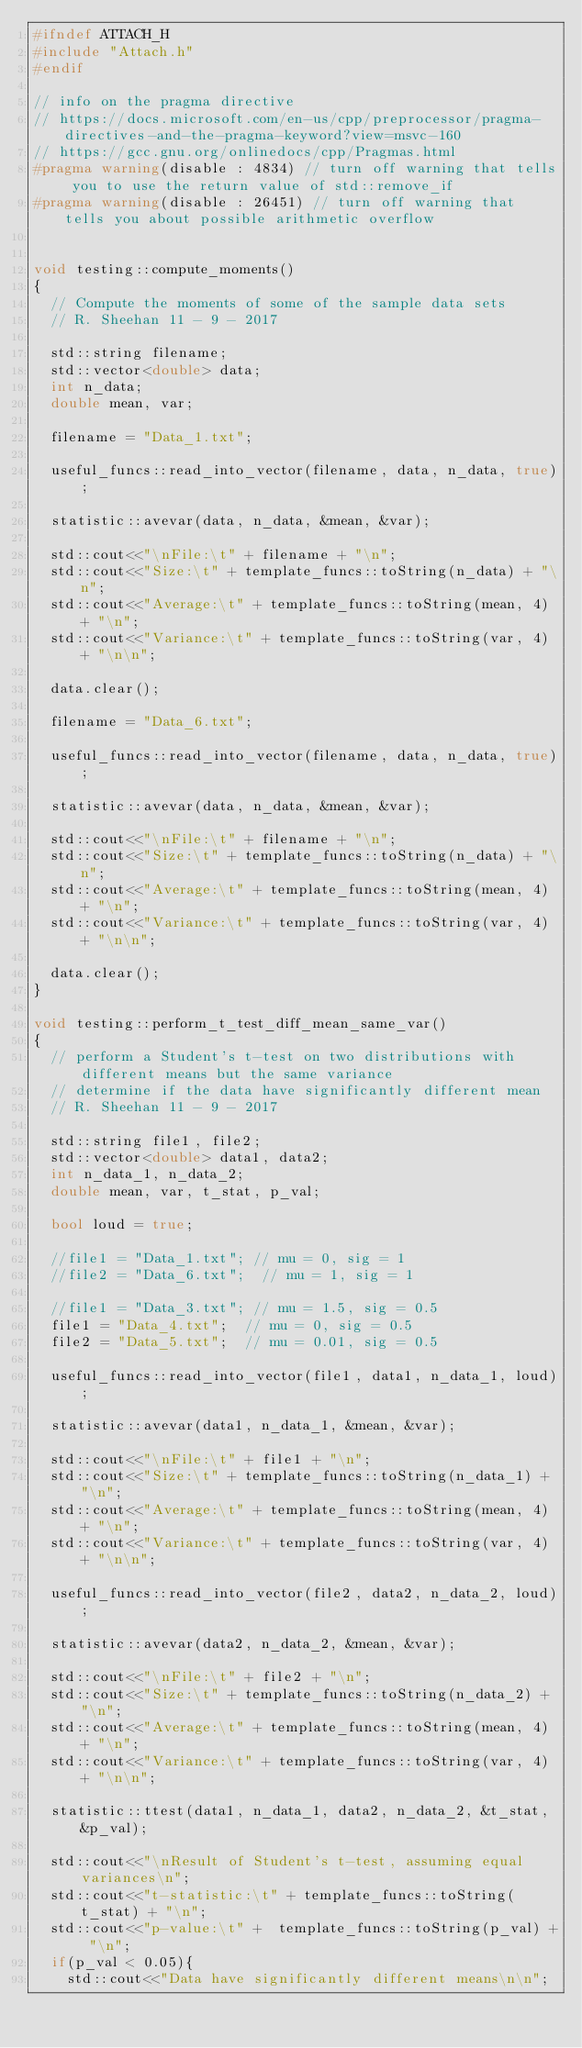Convert code to text. <code><loc_0><loc_0><loc_500><loc_500><_C++_>#ifndef ATTACH_H
#include "Attach.h"
#endif

// info on the pragma directive
// https://docs.microsoft.com/en-us/cpp/preprocessor/pragma-directives-and-the-pragma-keyword?view=msvc-160
// https://gcc.gnu.org/onlinedocs/cpp/Pragmas.html
#pragma warning(disable : 4834) // turn off warning that tells you to use the return value of std::remove_if
#pragma warning(disable : 26451) // turn off warning that tells you about possible arithmetic overflow


void testing::compute_moments()
{
	// Compute the moments of some of the sample data sets
	// R. Sheehan 11 - 9 - 2017

	std::string filename; 
	std::vector<double> data;
	int n_data; 
	double mean, var;

	filename = "Data_1.txt";  
	
	useful_funcs::read_into_vector(filename, data, n_data, true); 

	statistic::avevar(data, n_data, &mean, &var);

	std::cout<<"\nFile:\t" + filename + "\n"; 
	std::cout<<"Size:\t" + template_funcs::toString(n_data) + "\n"; 
	std::cout<<"Average:\t" + template_funcs::toString(mean, 4) + "\n"; 
	std::cout<<"Variance:\t" + template_funcs::toString(var, 4) + "\n\n"; 

	data.clear(); 

	filename = "Data_6.txt"; 
	
	useful_funcs::read_into_vector(filename, data, n_data, true); 

	statistic::avevar(data, n_data, &mean, &var);

	std::cout<<"\nFile:\t" + filename + "\n"; 
	std::cout<<"Size:\t" + template_funcs::toString(n_data) + "\n"; 
	std::cout<<"Average:\t" + template_funcs::toString(mean, 4) + "\n"; 
	std::cout<<"Variance:\t" + template_funcs::toString(var, 4) + "\n\n"; 

	data.clear(); 
}

void testing::perform_t_test_diff_mean_same_var()
{
	// perform a Student's t-test on two distributions with different means but the same variance
	// determine if the data have significantly different mean
	// R. Sheehan 11 - 9 - 2017

	std::string file1, file2; 
	std::vector<double> data1, data2;
	int n_data_1, n_data_2;
	double mean, var, t_stat, p_val; 

	bool loud = true; 

	//file1 = "Data_1.txt"; // mu = 0, sig = 1
	//file2 = "Data_6.txt";  // mu = 1, sig = 1

	//file1 = "Data_3.txt"; // mu = 1.5, sig = 0.5
	file1 = "Data_4.txt";  // mu = 0, sig = 0.5
	file2 = "Data_5.txt";  // mu = 0.01, sig = 0.5

	useful_funcs::read_into_vector(file1, data1, n_data_1, loud);

	statistic::avevar(data1, n_data_1, &mean, &var);

	std::cout<<"\nFile:\t" + file1 + "\n"; 
	std::cout<<"Size:\t" + template_funcs::toString(n_data_1) + "\n"; 
	std::cout<<"Average:\t" + template_funcs::toString(mean, 4) + "\n"; 
	std::cout<<"Variance:\t" + template_funcs::toString(var, 4) + "\n\n";

	useful_funcs::read_into_vector(file2, data2, n_data_2, loud);

	statistic::avevar(data2, n_data_2, &mean, &var);

	std::cout<<"\nFile:\t" + file2 + "\n"; 
	std::cout<<"Size:\t" + template_funcs::toString(n_data_2) + "\n"; 
	std::cout<<"Average:\t" + template_funcs::toString(mean, 4) + "\n"; 
	std::cout<<"Variance:\t" + template_funcs::toString(var, 4) + "\n\n";

	statistic::ttest(data1, n_data_1, data2, n_data_2, &t_stat, &p_val);

	std::cout<<"\nResult of Student's t-test, assuming equal variances\n";
	std::cout<<"t-statistic:\t" + template_funcs::toString(t_stat) + "\n"; 
	std::cout<<"p-value:\t" +  template_funcs::toString(p_val) + "\n"; 
	if(p_val < 0.05){
		std::cout<<"Data have significantly different means\n\n";</code> 